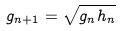<formula> <loc_0><loc_0><loc_500><loc_500>g _ { n + 1 } = \sqrt { g _ { n } h _ { n } }</formula> 